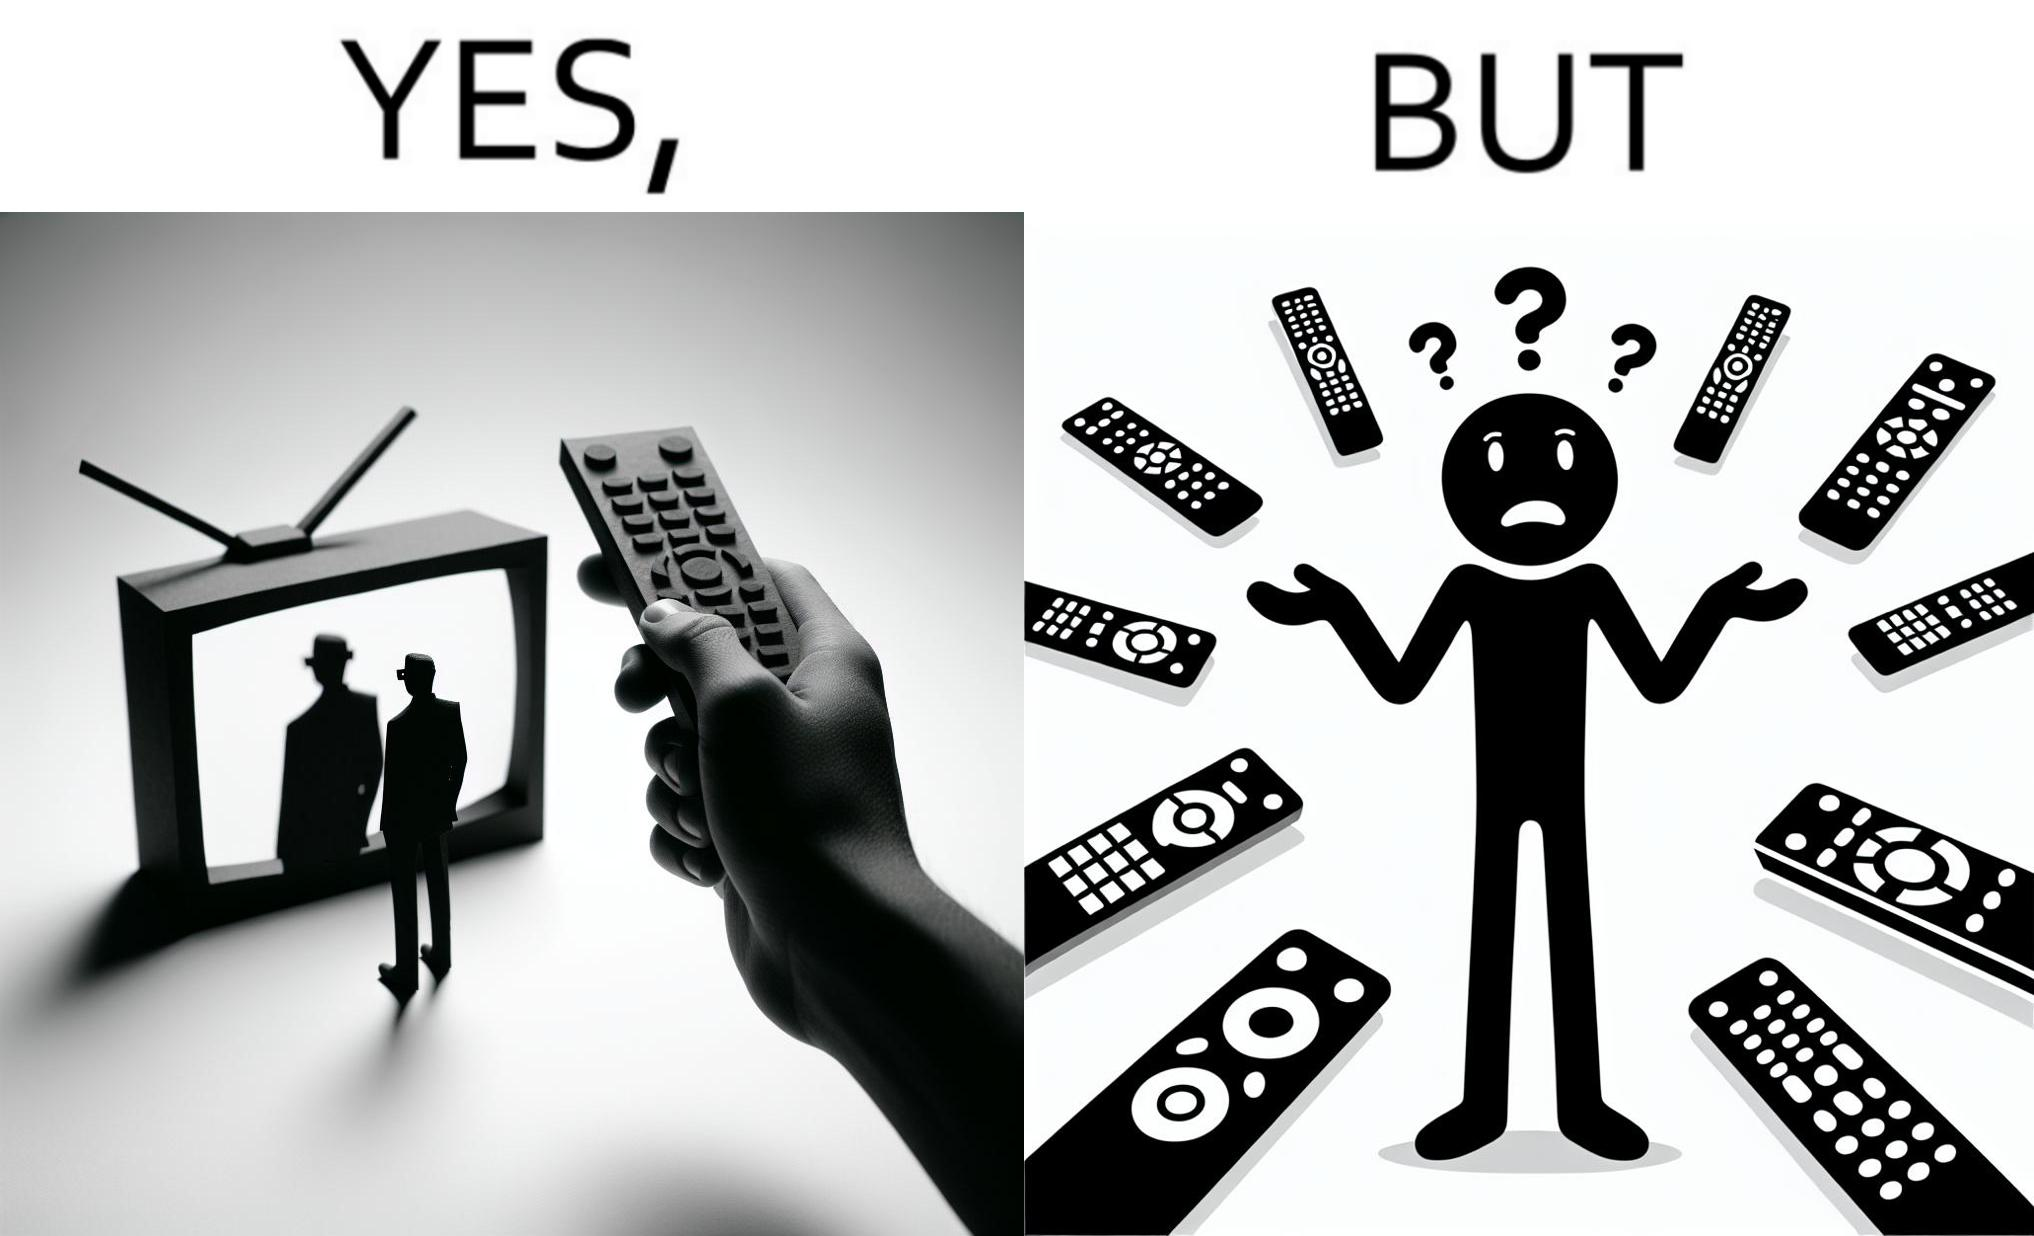Would you classify this image as satirical? Yes, this image is satirical. 